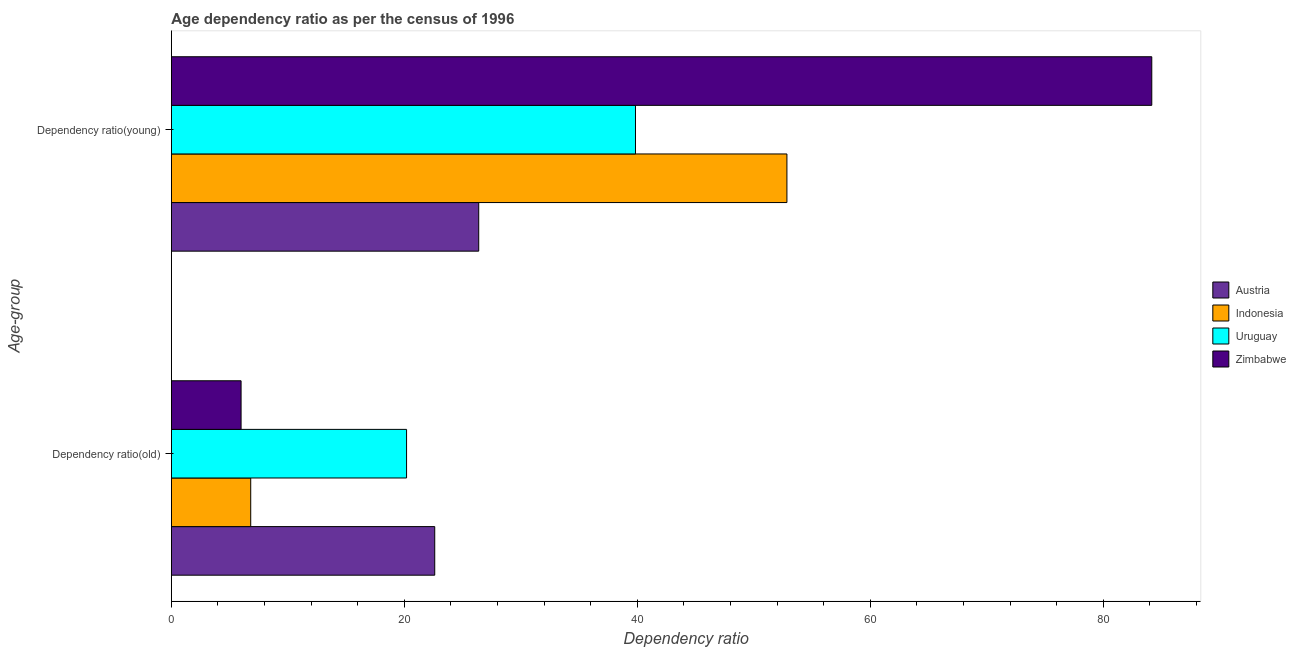How many different coloured bars are there?
Keep it short and to the point. 4. How many groups of bars are there?
Your answer should be very brief. 2. How many bars are there on the 2nd tick from the top?
Your answer should be very brief. 4. How many bars are there on the 1st tick from the bottom?
Offer a terse response. 4. What is the label of the 1st group of bars from the top?
Keep it short and to the point. Dependency ratio(young). What is the age dependency ratio(young) in Austria?
Your answer should be very brief. 26.38. Across all countries, what is the maximum age dependency ratio(old)?
Give a very brief answer. 22.61. Across all countries, what is the minimum age dependency ratio(old)?
Keep it short and to the point. 5.98. What is the total age dependency ratio(old) in the graph?
Offer a terse response. 55.59. What is the difference between the age dependency ratio(young) in Uruguay and that in Zimbabwe?
Your response must be concise. -44.32. What is the difference between the age dependency ratio(old) in Austria and the age dependency ratio(young) in Uruguay?
Provide a succinct answer. -17.23. What is the average age dependency ratio(young) per country?
Provide a short and direct response. 50.81. What is the difference between the age dependency ratio(old) and age dependency ratio(young) in Austria?
Ensure brevity in your answer.  -3.78. In how many countries, is the age dependency ratio(old) greater than 36 ?
Give a very brief answer. 0. What is the ratio of the age dependency ratio(young) in Uruguay to that in Zimbabwe?
Your answer should be compact. 0.47. What does the 2nd bar from the top in Dependency ratio(old) represents?
Your answer should be compact. Uruguay. What does the 1st bar from the bottom in Dependency ratio(old) represents?
Make the answer very short. Austria. What is the difference between two consecutive major ticks on the X-axis?
Your answer should be compact. 20. Does the graph contain any zero values?
Offer a terse response. No. Where does the legend appear in the graph?
Provide a succinct answer. Center right. How are the legend labels stacked?
Provide a short and direct response. Vertical. What is the title of the graph?
Offer a terse response. Age dependency ratio as per the census of 1996. Does "High income" appear as one of the legend labels in the graph?
Ensure brevity in your answer.  No. What is the label or title of the X-axis?
Your answer should be compact. Dependency ratio. What is the label or title of the Y-axis?
Your response must be concise. Age-group. What is the Dependency ratio of Austria in Dependency ratio(old)?
Keep it short and to the point. 22.61. What is the Dependency ratio in Indonesia in Dependency ratio(old)?
Make the answer very short. 6.81. What is the Dependency ratio in Uruguay in Dependency ratio(old)?
Provide a short and direct response. 20.19. What is the Dependency ratio in Zimbabwe in Dependency ratio(old)?
Offer a terse response. 5.98. What is the Dependency ratio in Austria in Dependency ratio(young)?
Make the answer very short. 26.38. What is the Dependency ratio of Indonesia in Dependency ratio(young)?
Your answer should be very brief. 52.84. What is the Dependency ratio in Uruguay in Dependency ratio(young)?
Your response must be concise. 39.84. What is the Dependency ratio of Zimbabwe in Dependency ratio(young)?
Keep it short and to the point. 84.17. Across all Age-group, what is the maximum Dependency ratio in Austria?
Offer a very short reply. 26.38. Across all Age-group, what is the maximum Dependency ratio of Indonesia?
Provide a succinct answer. 52.84. Across all Age-group, what is the maximum Dependency ratio in Uruguay?
Provide a short and direct response. 39.84. Across all Age-group, what is the maximum Dependency ratio in Zimbabwe?
Give a very brief answer. 84.17. Across all Age-group, what is the minimum Dependency ratio of Austria?
Provide a short and direct response. 22.61. Across all Age-group, what is the minimum Dependency ratio in Indonesia?
Give a very brief answer. 6.81. Across all Age-group, what is the minimum Dependency ratio in Uruguay?
Ensure brevity in your answer.  20.19. Across all Age-group, what is the minimum Dependency ratio of Zimbabwe?
Ensure brevity in your answer.  5.98. What is the total Dependency ratio in Austria in the graph?
Your response must be concise. 48.99. What is the total Dependency ratio in Indonesia in the graph?
Your answer should be very brief. 59.66. What is the total Dependency ratio in Uruguay in the graph?
Your answer should be very brief. 60.03. What is the total Dependency ratio of Zimbabwe in the graph?
Offer a terse response. 90.15. What is the difference between the Dependency ratio of Austria in Dependency ratio(old) and that in Dependency ratio(young)?
Give a very brief answer. -3.78. What is the difference between the Dependency ratio of Indonesia in Dependency ratio(old) and that in Dependency ratio(young)?
Provide a succinct answer. -46.03. What is the difference between the Dependency ratio in Uruguay in Dependency ratio(old) and that in Dependency ratio(young)?
Provide a short and direct response. -19.65. What is the difference between the Dependency ratio in Zimbabwe in Dependency ratio(old) and that in Dependency ratio(young)?
Your answer should be compact. -78.18. What is the difference between the Dependency ratio of Austria in Dependency ratio(old) and the Dependency ratio of Indonesia in Dependency ratio(young)?
Your response must be concise. -30.23. What is the difference between the Dependency ratio in Austria in Dependency ratio(old) and the Dependency ratio in Uruguay in Dependency ratio(young)?
Offer a terse response. -17.23. What is the difference between the Dependency ratio of Austria in Dependency ratio(old) and the Dependency ratio of Zimbabwe in Dependency ratio(young)?
Provide a succinct answer. -61.56. What is the difference between the Dependency ratio of Indonesia in Dependency ratio(old) and the Dependency ratio of Uruguay in Dependency ratio(young)?
Your response must be concise. -33.03. What is the difference between the Dependency ratio in Indonesia in Dependency ratio(old) and the Dependency ratio in Zimbabwe in Dependency ratio(young)?
Your answer should be very brief. -77.36. What is the difference between the Dependency ratio of Uruguay in Dependency ratio(old) and the Dependency ratio of Zimbabwe in Dependency ratio(young)?
Your answer should be compact. -63.98. What is the average Dependency ratio of Austria per Age-group?
Your answer should be compact. 24.5. What is the average Dependency ratio of Indonesia per Age-group?
Your response must be concise. 29.83. What is the average Dependency ratio in Uruguay per Age-group?
Offer a very short reply. 30.02. What is the average Dependency ratio of Zimbabwe per Age-group?
Offer a very short reply. 45.08. What is the difference between the Dependency ratio in Austria and Dependency ratio in Indonesia in Dependency ratio(old)?
Ensure brevity in your answer.  15.8. What is the difference between the Dependency ratio of Austria and Dependency ratio of Uruguay in Dependency ratio(old)?
Offer a terse response. 2.42. What is the difference between the Dependency ratio of Austria and Dependency ratio of Zimbabwe in Dependency ratio(old)?
Give a very brief answer. 16.63. What is the difference between the Dependency ratio in Indonesia and Dependency ratio in Uruguay in Dependency ratio(old)?
Make the answer very short. -13.38. What is the difference between the Dependency ratio of Indonesia and Dependency ratio of Zimbabwe in Dependency ratio(old)?
Offer a very short reply. 0.83. What is the difference between the Dependency ratio of Uruguay and Dependency ratio of Zimbabwe in Dependency ratio(old)?
Provide a succinct answer. 14.21. What is the difference between the Dependency ratio of Austria and Dependency ratio of Indonesia in Dependency ratio(young)?
Offer a very short reply. -26.46. What is the difference between the Dependency ratio of Austria and Dependency ratio of Uruguay in Dependency ratio(young)?
Give a very brief answer. -13.46. What is the difference between the Dependency ratio of Austria and Dependency ratio of Zimbabwe in Dependency ratio(young)?
Your response must be concise. -57.78. What is the difference between the Dependency ratio in Indonesia and Dependency ratio in Uruguay in Dependency ratio(young)?
Your answer should be compact. 13. What is the difference between the Dependency ratio of Indonesia and Dependency ratio of Zimbabwe in Dependency ratio(young)?
Your answer should be very brief. -31.32. What is the difference between the Dependency ratio of Uruguay and Dependency ratio of Zimbabwe in Dependency ratio(young)?
Your answer should be compact. -44.32. What is the ratio of the Dependency ratio in Austria in Dependency ratio(old) to that in Dependency ratio(young)?
Offer a terse response. 0.86. What is the ratio of the Dependency ratio in Indonesia in Dependency ratio(old) to that in Dependency ratio(young)?
Ensure brevity in your answer.  0.13. What is the ratio of the Dependency ratio in Uruguay in Dependency ratio(old) to that in Dependency ratio(young)?
Your answer should be compact. 0.51. What is the ratio of the Dependency ratio in Zimbabwe in Dependency ratio(old) to that in Dependency ratio(young)?
Provide a succinct answer. 0.07. What is the difference between the highest and the second highest Dependency ratio of Austria?
Your answer should be compact. 3.78. What is the difference between the highest and the second highest Dependency ratio of Indonesia?
Provide a short and direct response. 46.03. What is the difference between the highest and the second highest Dependency ratio of Uruguay?
Offer a terse response. 19.65. What is the difference between the highest and the second highest Dependency ratio in Zimbabwe?
Your answer should be very brief. 78.18. What is the difference between the highest and the lowest Dependency ratio in Austria?
Keep it short and to the point. 3.78. What is the difference between the highest and the lowest Dependency ratio in Indonesia?
Your answer should be very brief. 46.03. What is the difference between the highest and the lowest Dependency ratio of Uruguay?
Offer a terse response. 19.65. What is the difference between the highest and the lowest Dependency ratio in Zimbabwe?
Offer a very short reply. 78.18. 